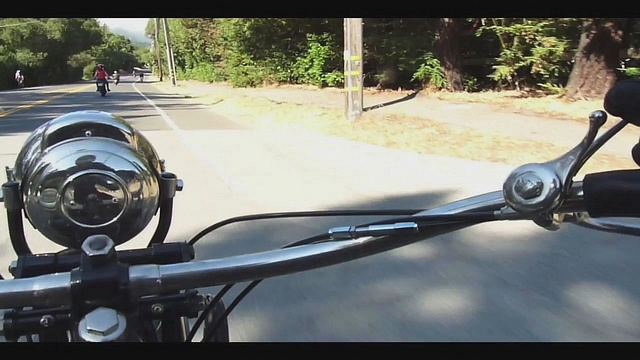Describe the objects in this image and their specific colors. I can see motorcycle in black, gray, darkgray, and lightgray tones, bicycle in black, gray, lightgray, and darkgray tones, people in black, maroon, gray, and brown tones, motorcycle in black and gray tones, and people in black, darkgray, gray, and lightgray tones in this image. 